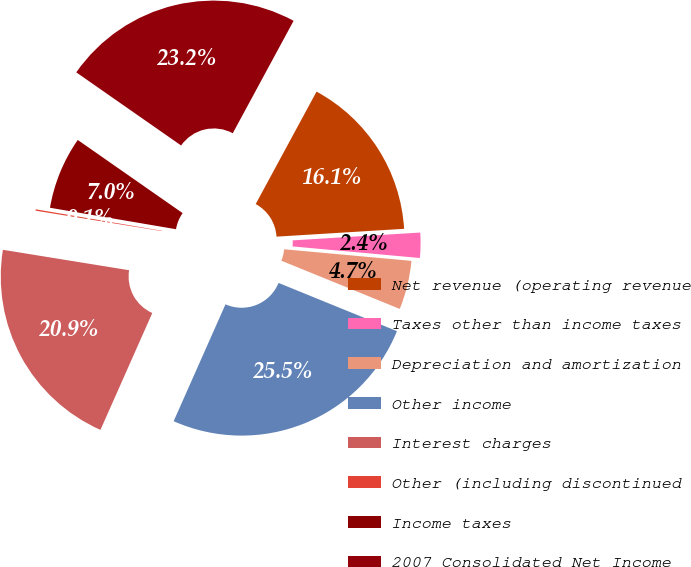Convert chart to OTSL. <chart><loc_0><loc_0><loc_500><loc_500><pie_chart><fcel>Net revenue (operating revenue<fcel>Taxes other than income taxes<fcel>Depreciation and amortization<fcel>Other income<fcel>Interest charges<fcel>Other (including discontinued<fcel>Income taxes<fcel>2007 Consolidated Net Income<nl><fcel>16.13%<fcel>2.42%<fcel>4.71%<fcel>25.49%<fcel>20.91%<fcel>0.13%<fcel>7.01%<fcel>23.2%<nl></chart> 